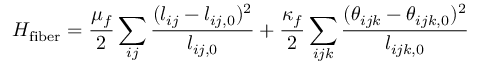<formula> <loc_0><loc_0><loc_500><loc_500>H _ { f i b e r } = \frac { \mu _ { f } } { 2 } \sum _ { i j } \frac { ( l _ { i j } - l _ { i j , 0 } ) ^ { 2 } } { l _ { i j , 0 } } + \frac { \kappa _ { f } } { 2 } \sum _ { i j k } \frac { ( \theta _ { i j k } - \theta _ { i j k , 0 } ) ^ { 2 } } { l _ { i j k , 0 } }</formula> 